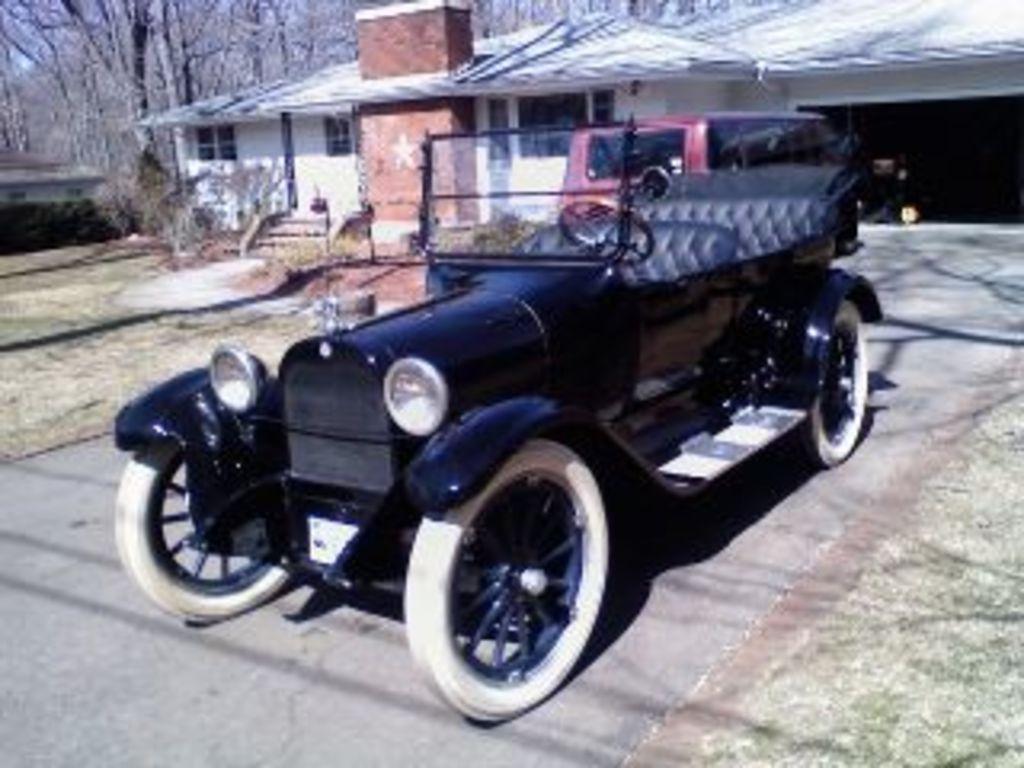Please provide a concise description of this image. In the foreground I can see a vehicle on the road and grass. In the background I can see a house, plants, steps, trees, person and houses. This image is taken may be during a day. 